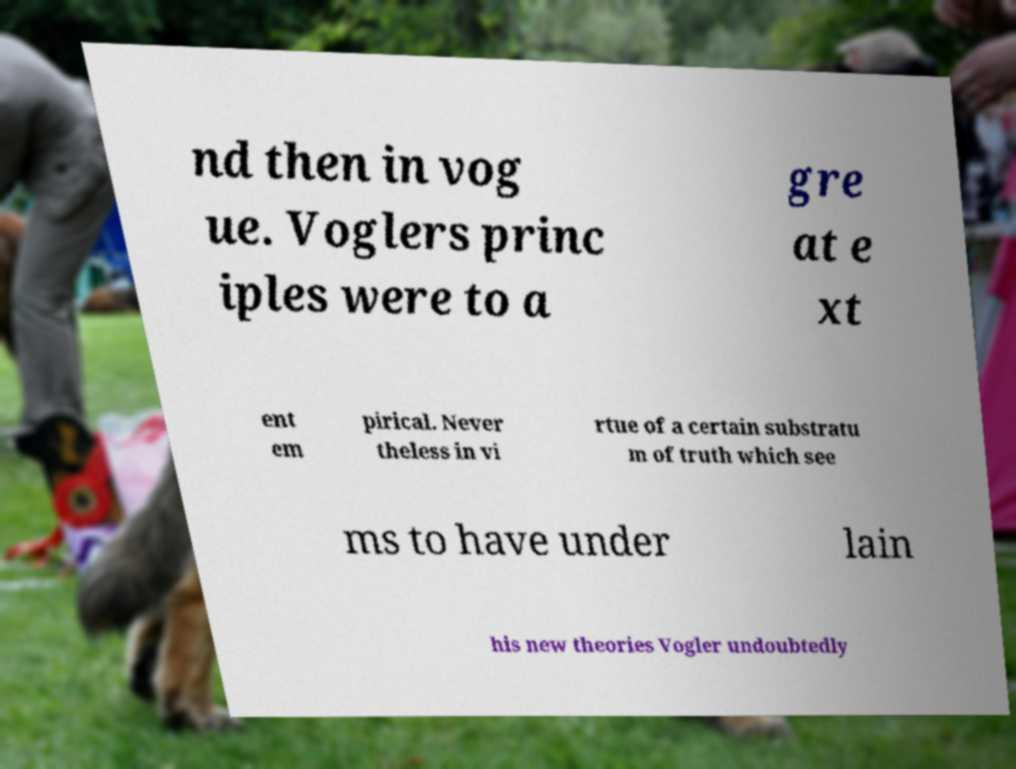Please read and relay the text visible in this image. What does it say? nd then in vog ue. Voglers princ iples were to a gre at e xt ent em pirical. Never theless in vi rtue of a certain substratu m of truth which see ms to have under lain his new theories Vogler undoubtedly 